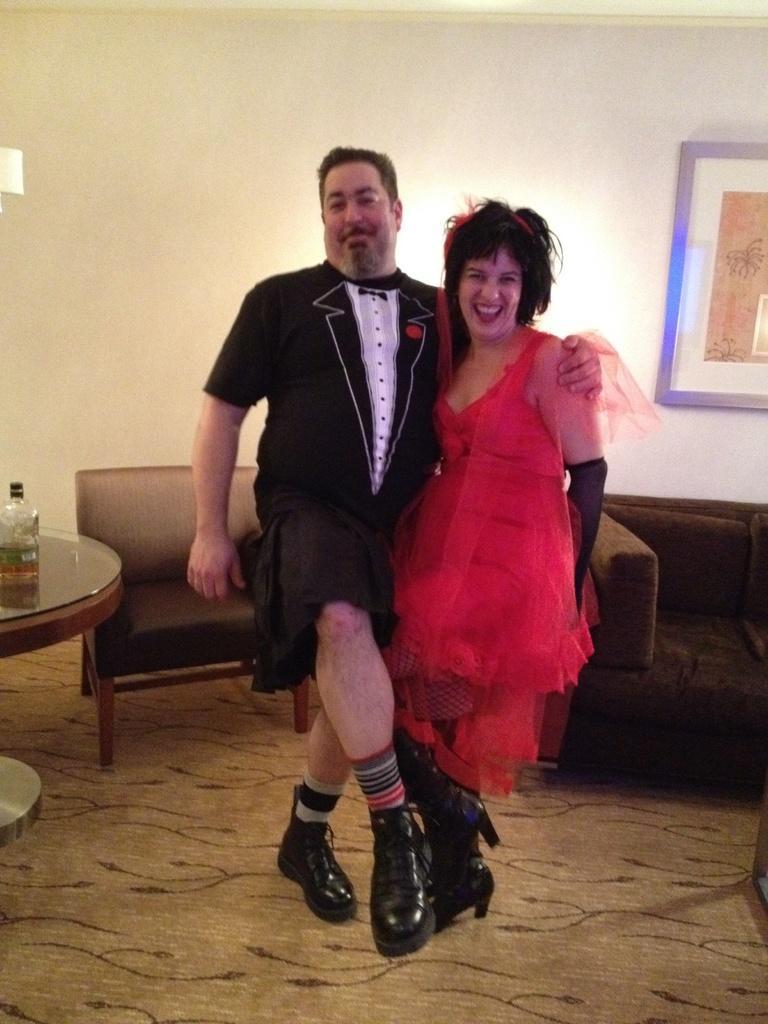How would you summarize this image in a sentence or two? As we can see in the image there is a wall, photo frame, sofas, table and two people standing over here. On table there is a bottle. 